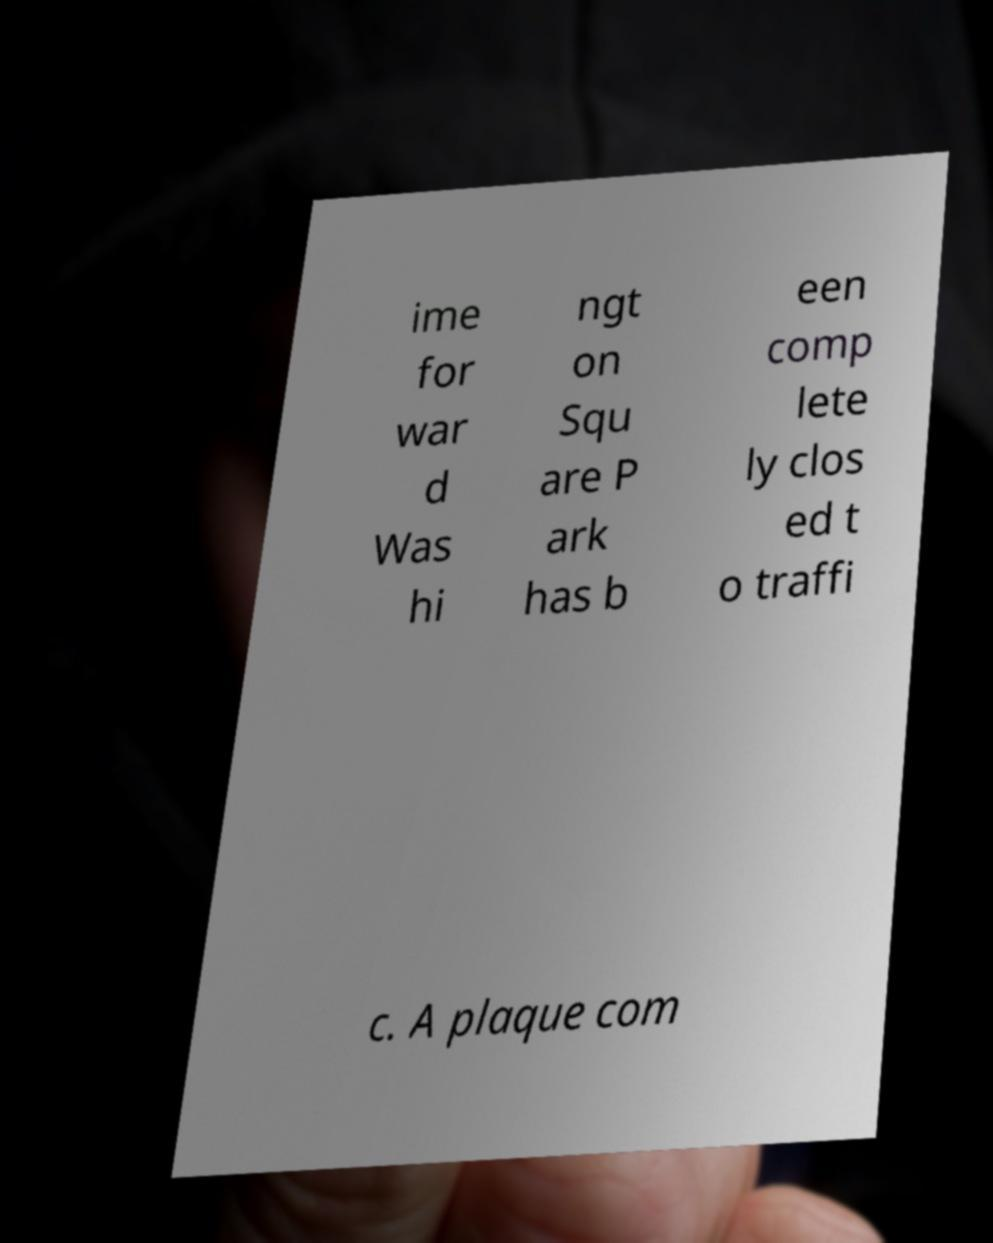Could you assist in decoding the text presented in this image and type it out clearly? ime for war d Was hi ngt on Squ are P ark has b een comp lete ly clos ed t o traffi c. A plaque com 